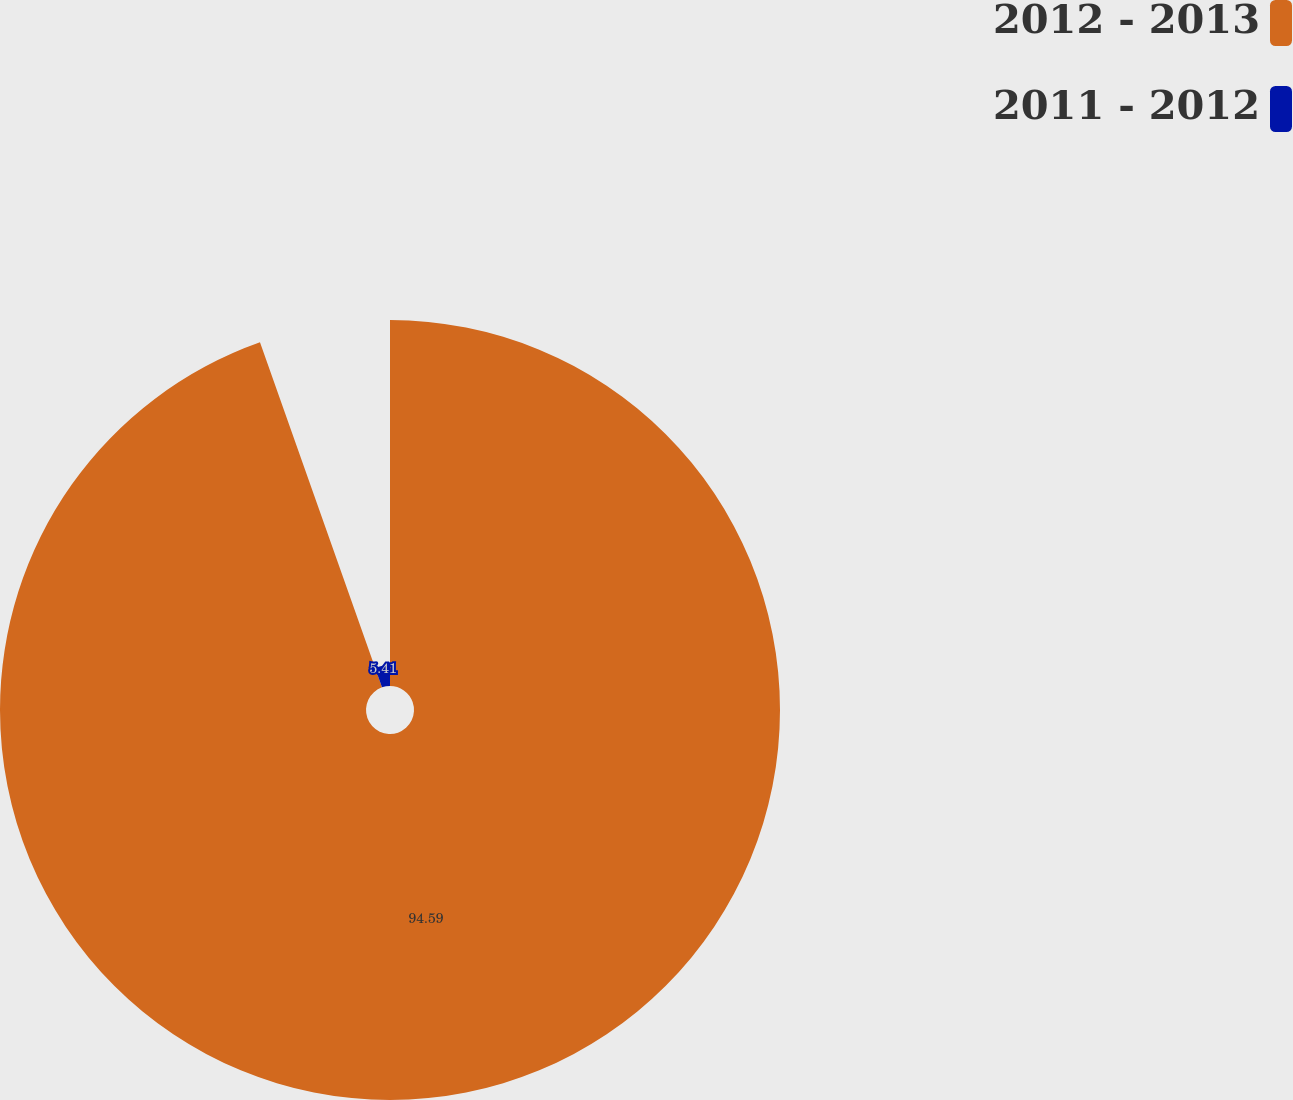Convert chart to OTSL. <chart><loc_0><loc_0><loc_500><loc_500><pie_chart><fcel>2012 - 2013<fcel>2011 - 2012<nl><fcel>94.59%<fcel>5.41%<nl></chart> 